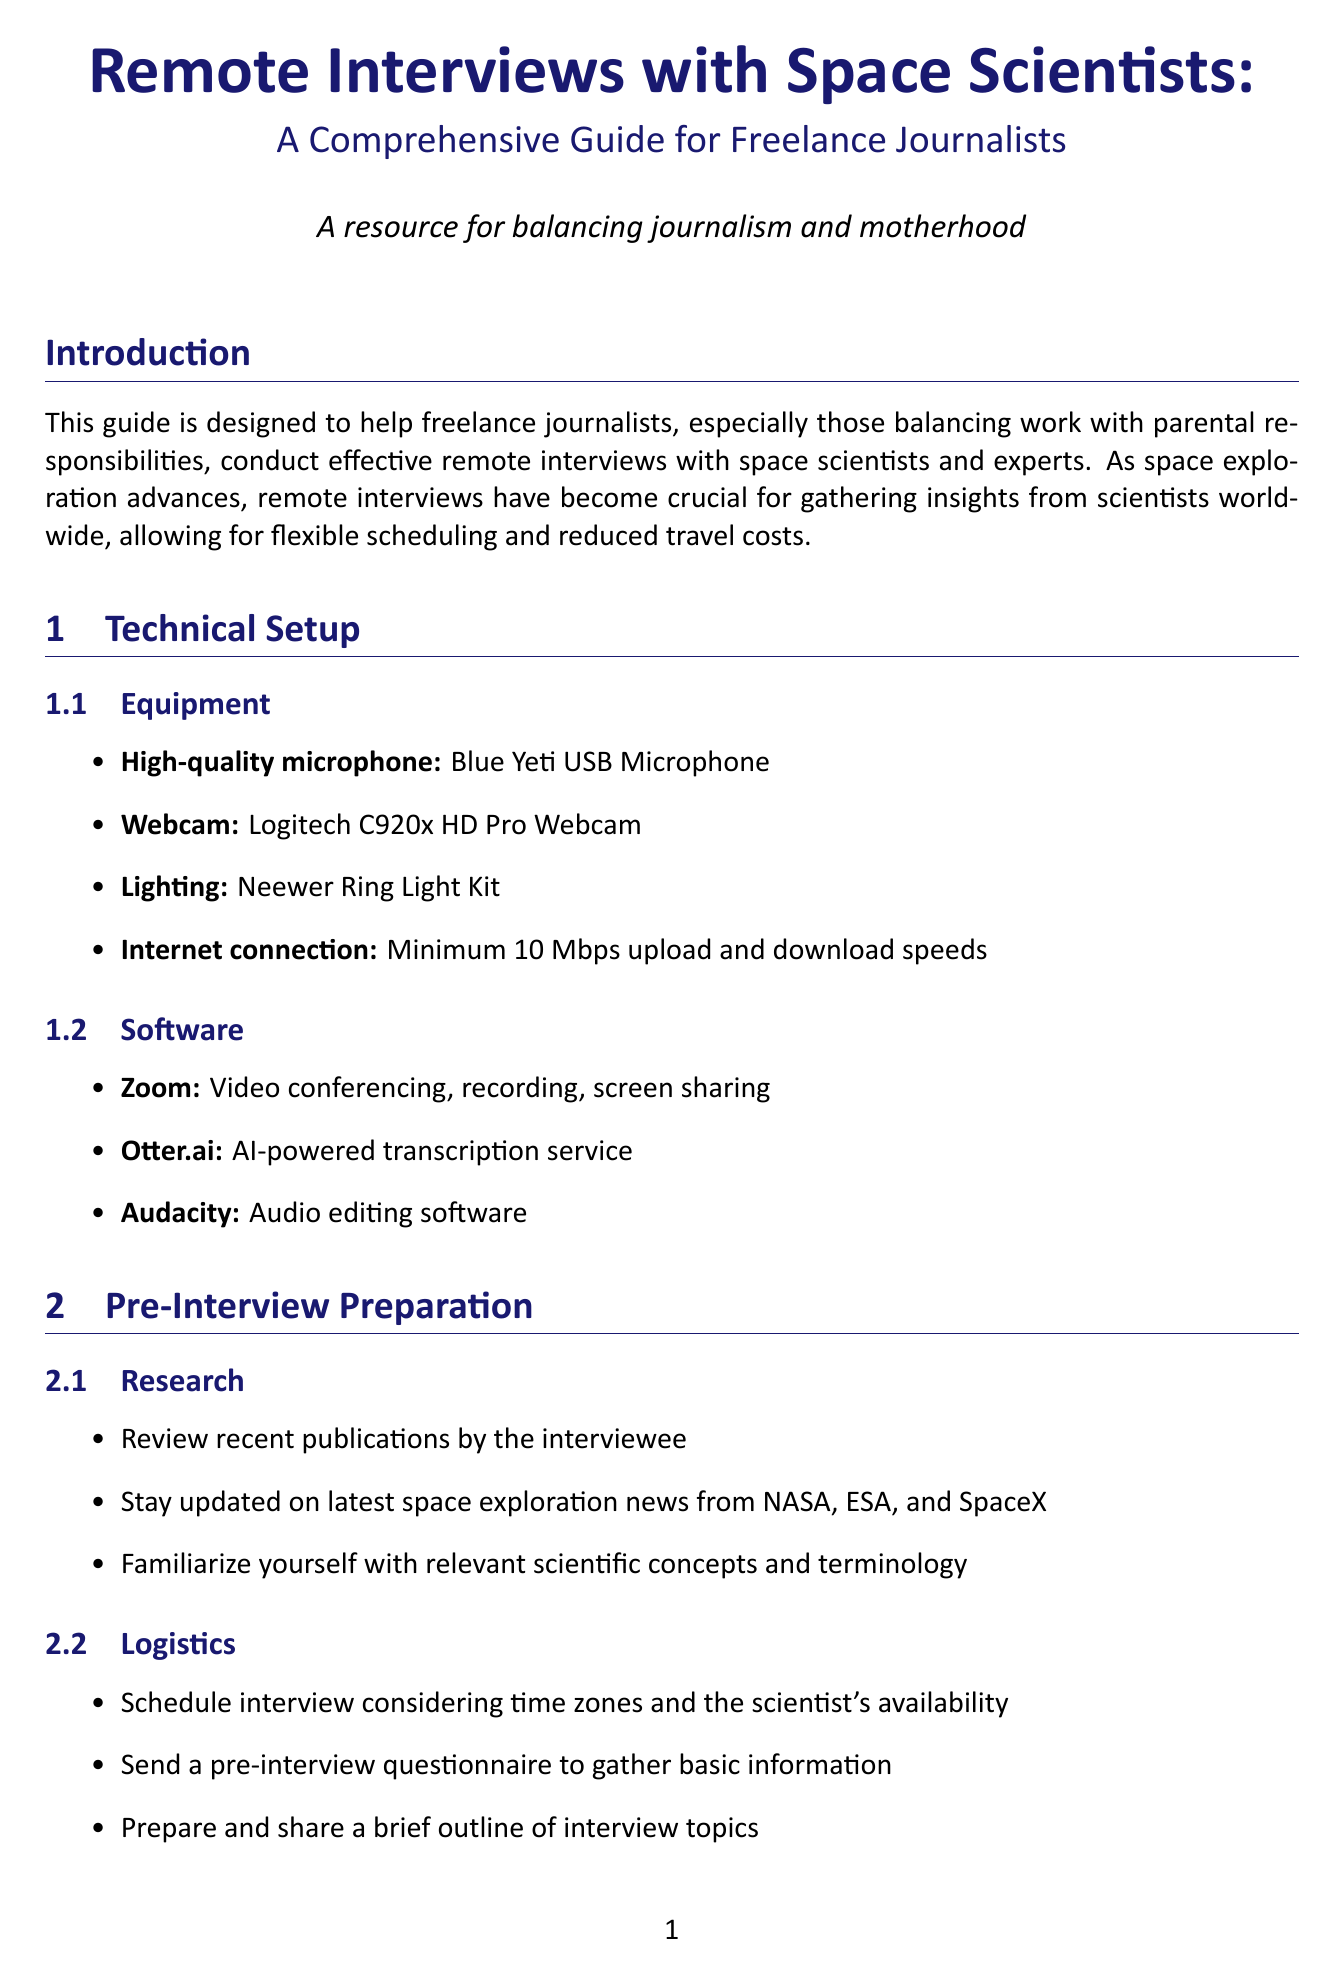What is the purpose of the guide? The purpose of the guide is to help freelance journalists, especially those balancing work with parental responsibilities, conduct effective remote interviews with space scientists and experts.
Answer: Help freelance journalists conduct effective remote interviews What is the recommended microphone? The recommended microphone is mentioned in the technical setup section of the document.
Answer: Blue Yeti USB Microphone What is the minimum internet speed recommended? The minimum internet speed is specified under the technical setup section.
Answer: Minimum 10 Mbps upload and download speeds What software is used for audio editing? The software for audio editing is stated in the software section.
Answer: Audacity Why is it important to review recent publications? It's important to review recent publications to stay informed about the interviewee's work.
Answer: To stay informed about the interviewee's work What environment setup tip is given for interviews? One tip provided for interview environment setup mentions considering childcare arrangements.
Answer: Considering childcare arrangements How should follow-up emails be structured post-interview? The follow-up email should thank the scientist, confirm permissions for quotes, and clarify points if necessary.
Answer: Thank the scientist, confirm any permissions for quotes, and clarify any points if needed When is it suggested to schedule interviews? The document suggests scheduling interviews during times when childcare is available.
Answer: During school hours or when childcare is available What is one of the noise-cancelling headphones used for? The document suggests using noise-cancelling headphones to maintain focus in a busy household.
Answer: To maintain focus in a busy household 